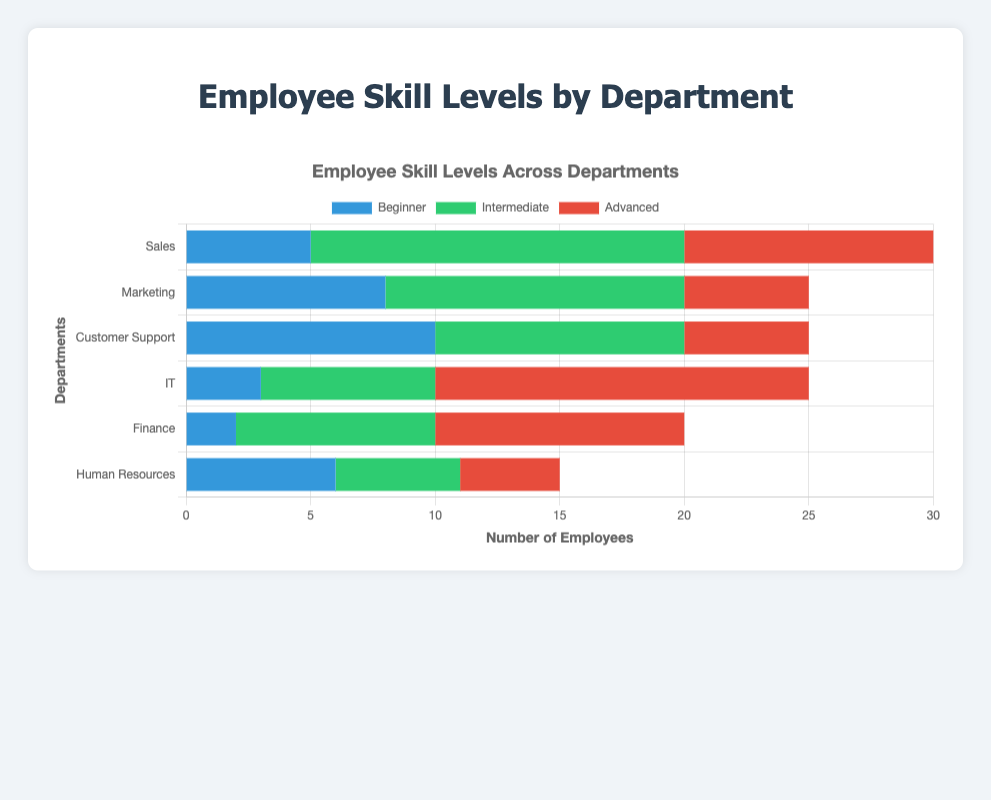Which department has the highest number of employees with advanced skills? The department with the highest red bar corresponds to the highest number of employees with advanced skills. IT has the highest red bar, indicating 15 advanced-skilled employees.
Answer: IT How many employees in the Sales department are either Intermediate or Advanced? Sum the heights of the green and red bars for the Sales department. The Sales department has 15 Intermediate and 10 Advanced employees. So, 15 + 10 = 25.
Answer: 25 Which department has the smallest number of Beginner employees? The department with the smallest blue bar corresponds to the smallest number of employees with Beginner skills. Finance has the smallest blue bar with only 2 Beginner employees.
Answer: Finance Compare the Intermediate skill levels of Marketing and Customer Support departments. Which has more, and by how much? The heights of the green bars for Marketing and Customer Support departments represent their Intermediate skill levels. Marketing has 12 and Customer Support has 10, thus Marketing has 2 more Intermediate-skilled employees than Customer Support.
Answer: Marketing by 2 What is the total number of employees in the Human Resources department? Sum the number of Beginner, Intermediate, and Advanced employees in Human Resources. Beginner: 6, Intermediate: 5, Advanced: 4. Total: 6 + 5 + 4 = 15.
Answer: 15 If we combine the number of Advanced employees in IT and Finance, does it exceed the total number of employees in Marketing? Sum the Advanced employees in IT (15) and Finance (10) and compare with the total employees in Marketing. Combined Advanced: 15 + 10 = 25. Total in Marketing: 8 + 12 + 5 = 25. 25 equals 25, so it does not exceed.
Answer: No, it equals Which department has the second-largest number of Intermediate employees? The department with the second-largest green bar corresponds to the second-largest number of Intermediate employees. Sales has the largest with 15, and Marketing has the next largest with 12.
Answer: Marketing What is the average number of Beginner employees across all departments? To find the average, sum the number of Beginner employees in each department, then divide by the number of departments. Sum: 5 + 8 + 10 + 3 + 2 + 6 = 34. Average: 34 / 6 ≈ 5.67.
Answer: Approximately 5.67 For the Customer Support department, which skill level has the least number of employees? Compare the lengths of the bars within the Customer Support department. The red bar (Advanced) is the shortest with 5 employees.
Answer: Advanced 